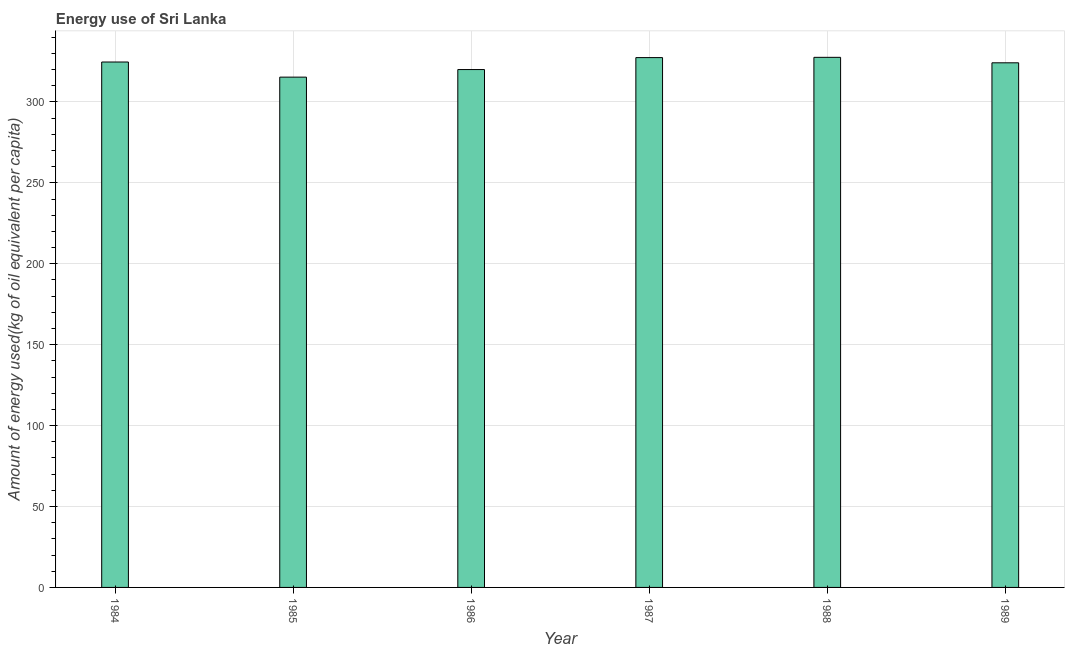Does the graph contain grids?
Offer a very short reply. Yes. What is the title of the graph?
Provide a short and direct response. Energy use of Sri Lanka. What is the label or title of the X-axis?
Your answer should be compact. Year. What is the label or title of the Y-axis?
Offer a very short reply. Amount of energy used(kg of oil equivalent per capita). What is the amount of energy used in 1986?
Ensure brevity in your answer.  320.02. Across all years, what is the maximum amount of energy used?
Your answer should be compact. 327.58. Across all years, what is the minimum amount of energy used?
Provide a succinct answer. 315.34. In which year was the amount of energy used maximum?
Offer a very short reply. 1988. What is the sum of the amount of energy used?
Offer a terse response. 1939.23. What is the difference between the amount of energy used in 1984 and 1985?
Give a very brief answer. 9.35. What is the average amount of energy used per year?
Your answer should be very brief. 323.2. What is the median amount of energy used?
Provide a short and direct response. 324.44. Do a majority of the years between 1986 and 1985 (inclusive) have amount of energy used greater than 130 kg?
Ensure brevity in your answer.  No. Is the amount of energy used in 1986 less than that in 1988?
Provide a succinct answer. Yes. Is the difference between the amount of energy used in 1985 and 1987 greater than the difference between any two years?
Your response must be concise. No. What is the difference between the highest and the second highest amount of energy used?
Ensure brevity in your answer.  0.17. Is the sum of the amount of energy used in 1985 and 1988 greater than the maximum amount of energy used across all years?
Give a very brief answer. Yes. What is the difference between the highest and the lowest amount of energy used?
Provide a succinct answer. 12.24. In how many years, is the amount of energy used greater than the average amount of energy used taken over all years?
Offer a terse response. 4. Are all the bars in the graph horizontal?
Make the answer very short. No. How many years are there in the graph?
Provide a succinct answer. 6. What is the difference between two consecutive major ticks on the Y-axis?
Keep it short and to the point. 50. Are the values on the major ticks of Y-axis written in scientific E-notation?
Your response must be concise. No. What is the Amount of energy used(kg of oil equivalent per capita) in 1984?
Keep it short and to the point. 324.69. What is the Amount of energy used(kg of oil equivalent per capita) of 1985?
Provide a succinct answer. 315.34. What is the Amount of energy used(kg of oil equivalent per capita) of 1986?
Make the answer very short. 320.02. What is the Amount of energy used(kg of oil equivalent per capita) in 1987?
Provide a succinct answer. 327.41. What is the Amount of energy used(kg of oil equivalent per capita) in 1988?
Offer a terse response. 327.58. What is the Amount of energy used(kg of oil equivalent per capita) of 1989?
Provide a succinct answer. 324.19. What is the difference between the Amount of energy used(kg of oil equivalent per capita) in 1984 and 1985?
Keep it short and to the point. 9.35. What is the difference between the Amount of energy used(kg of oil equivalent per capita) in 1984 and 1986?
Your response must be concise. 4.67. What is the difference between the Amount of energy used(kg of oil equivalent per capita) in 1984 and 1987?
Make the answer very short. -2.72. What is the difference between the Amount of energy used(kg of oil equivalent per capita) in 1984 and 1988?
Ensure brevity in your answer.  -2.89. What is the difference between the Amount of energy used(kg of oil equivalent per capita) in 1984 and 1989?
Offer a terse response. 0.49. What is the difference between the Amount of energy used(kg of oil equivalent per capita) in 1985 and 1986?
Offer a terse response. -4.68. What is the difference between the Amount of energy used(kg of oil equivalent per capita) in 1985 and 1987?
Your answer should be very brief. -12.07. What is the difference between the Amount of energy used(kg of oil equivalent per capita) in 1985 and 1988?
Your answer should be compact. -12.24. What is the difference between the Amount of energy used(kg of oil equivalent per capita) in 1985 and 1989?
Make the answer very short. -8.86. What is the difference between the Amount of energy used(kg of oil equivalent per capita) in 1986 and 1987?
Keep it short and to the point. -7.39. What is the difference between the Amount of energy used(kg of oil equivalent per capita) in 1986 and 1988?
Offer a terse response. -7.56. What is the difference between the Amount of energy used(kg of oil equivalent per capita) in 1986 and 1989?
Provide a succinct answer. -4.17. What is the difference between the Amount of energy used(kg of oil equivalent per capita) in 1987 and 1988?
Give a very brief answer. -0.17. What is the difference between the Amount of energy used(kg of oil equivalent per capita) in 1987 and 1989?
Keep it short and to the point. 3.22. What is the difference between the Amount of energy used(kg of oil equivalent per capita) in 1988 and 1989?
Your response must be concise. 3.38. What is the ratio of the Amount of energy used(kg of oil equivalent per capita) in 1984 to that in 1985?
Your response must be concise. 1.03. What is the ratio of the Amount of energy used(kg of oil equivalent per capita) in 1984 to that in 1988?
Offer a very short reply. 0.99. What is the ratio of the Amount of energy used(kg of oil equivalent per capita) in 1984 to that in 1989?
Offer a terse response. 1. What is the ratio of the Amount of energy used(kg of oil equivalent per capita) in 1985 to that in 1986?
Your response must be concise. 0.98. What is the ratio of the Amount of energy used(kg of oil equivalent per capita) in 1985 to that in 1987?
Offer a very short reply. 0.96. What is the ratio of the Amount of energy used(kg of oil equivalent per capita) in 1985 to that in 1989?
Your answer should be very brief. 0.97. What is the ratio of the Amount of energy used(kg of oil equivalent per capita) in 1986 to that in 1989?
Offer a terse response. 0.99. What is the ratio of the Amount of energy used(kg of oil equivalent per capita) in 1987 to that in 1988?
Offer a very short reply. 1. What is the ratio of the Amount of energy used(kg of oil equivalent per capita) in 1987 to that in 1989?
Provide a succinct answer. 1.01. What is the ratio of the Amount of energy used(kg of oil equivalent per capita) in 1988 to that in 1989?
Provide a short and direct response. 1.01. 